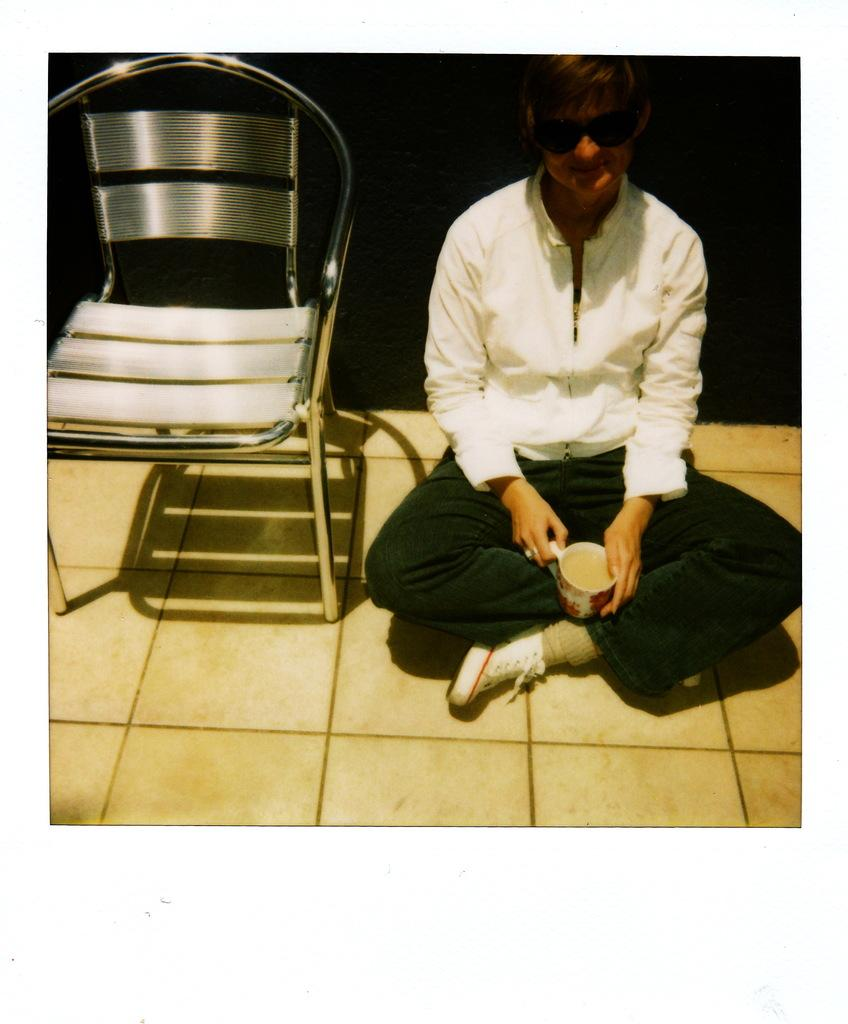What is the person in the image doing? The person is sitting on the floor in the image. What is the person holding in the image? The person is holding a cup. What piece of furniture is beside the person? There is a chair beside the person. What can be observed about the lighting in the image? The background of the image is dark. What type of discovery was made at the airport in the image? There is no airport or discovery present in the image; it features a person sitting on the floor holding a cup. How many times can the person fold the chair in the image? There is no folding of chairs in the image; the person is sitting on the floor, and a chair is beside them. 